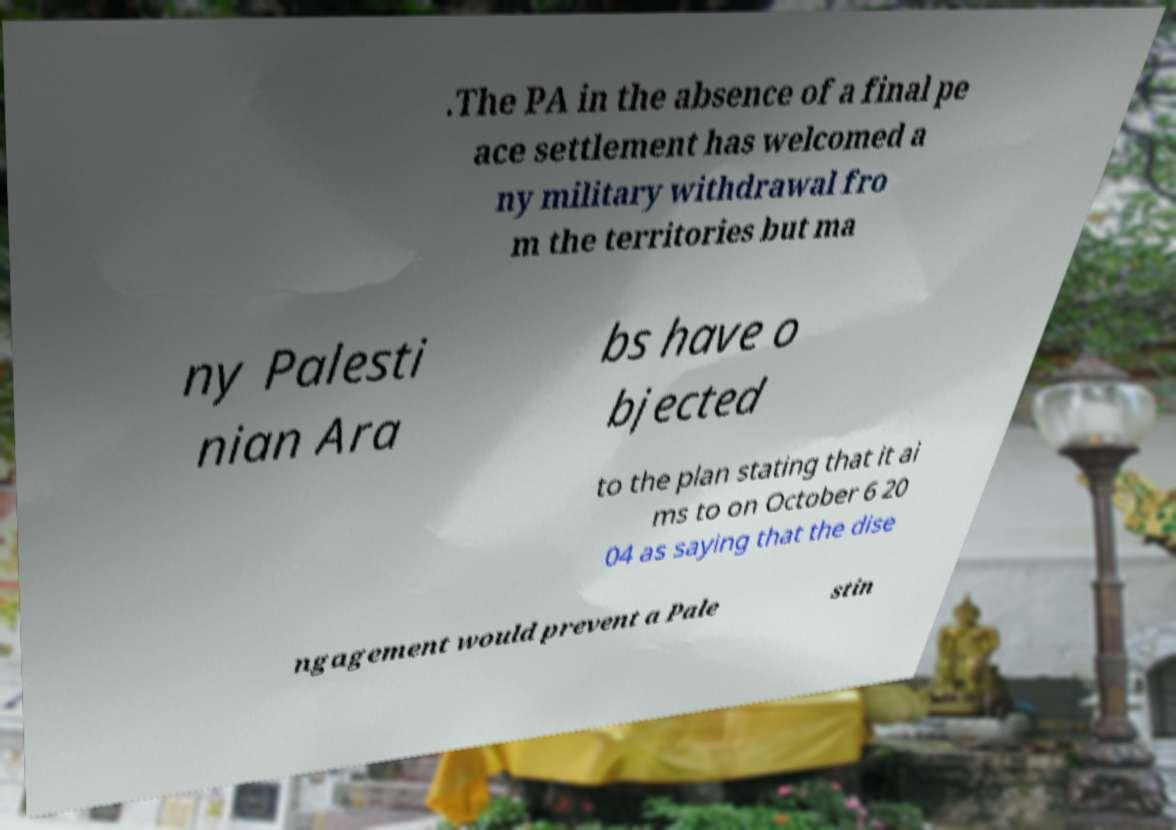Can you accurately transcribe the text from the provided image for me? .The PA in the absence of a final pe ace settlement has welcomed a ny military withdrawal fro m the territories but ma ny Palesti nian Ara bs have o bjected to the plan stating that it ai ms to on October 6 20 04 as saying that the dise ngagement would prevent a Pale stin 